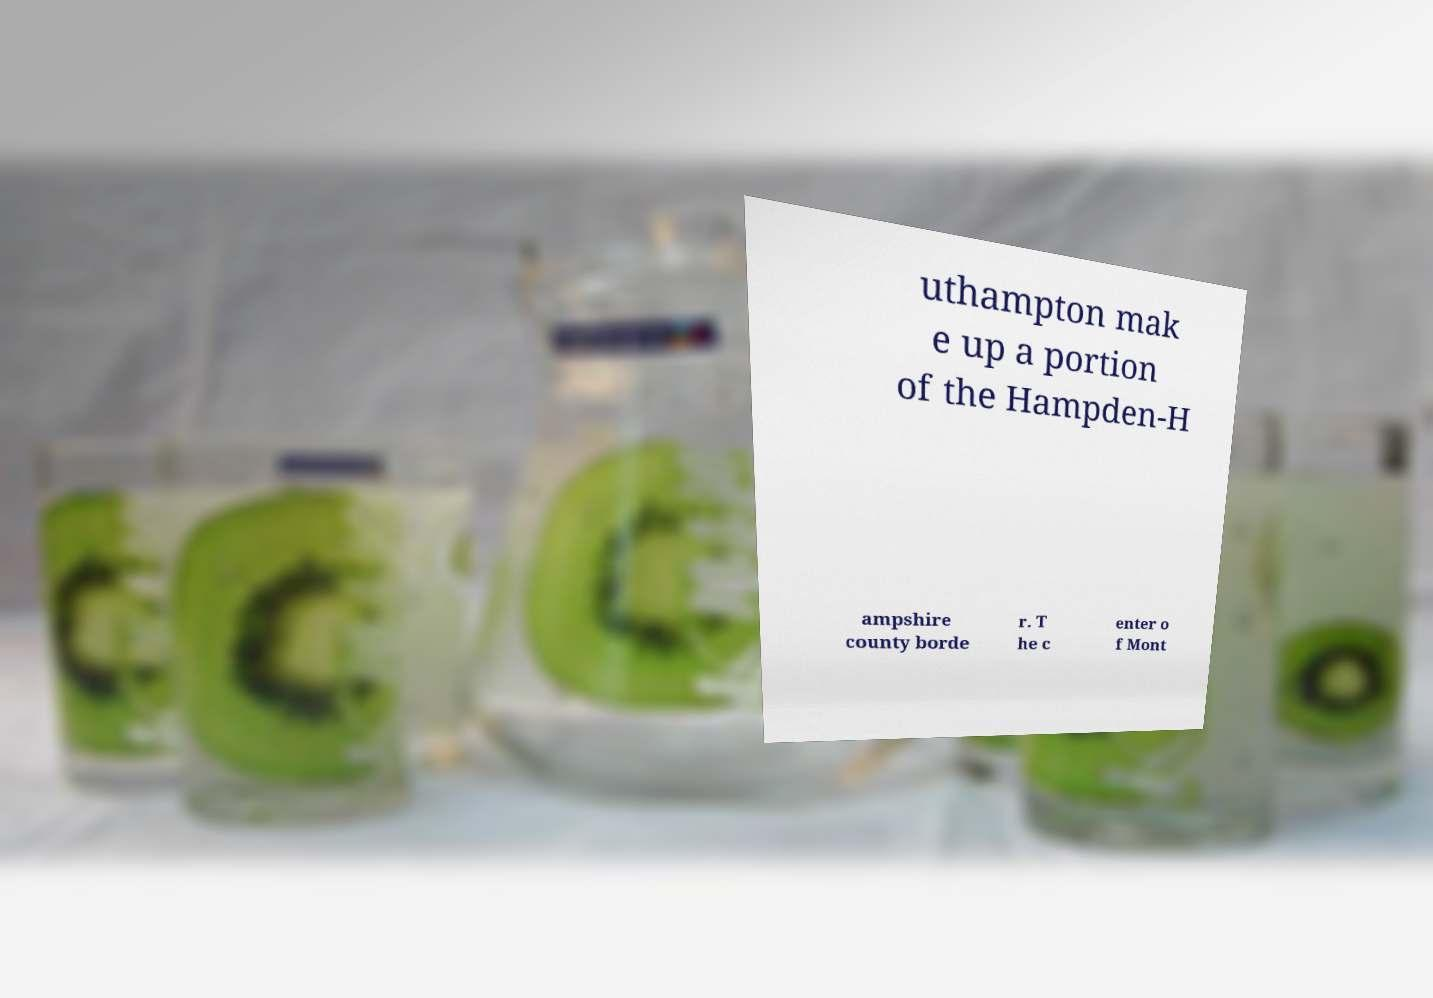For documentation purposes, I need the text within this image transcribed. Could you provide that? uthampton mak e up a portion of the Hampden-H ampshire county borde r. T he c enter o f Mont 